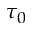Convert formula to latex. <formula><loc_0><loc_0><loc_500><loc_500>\tau _ { 0 }</formula> 